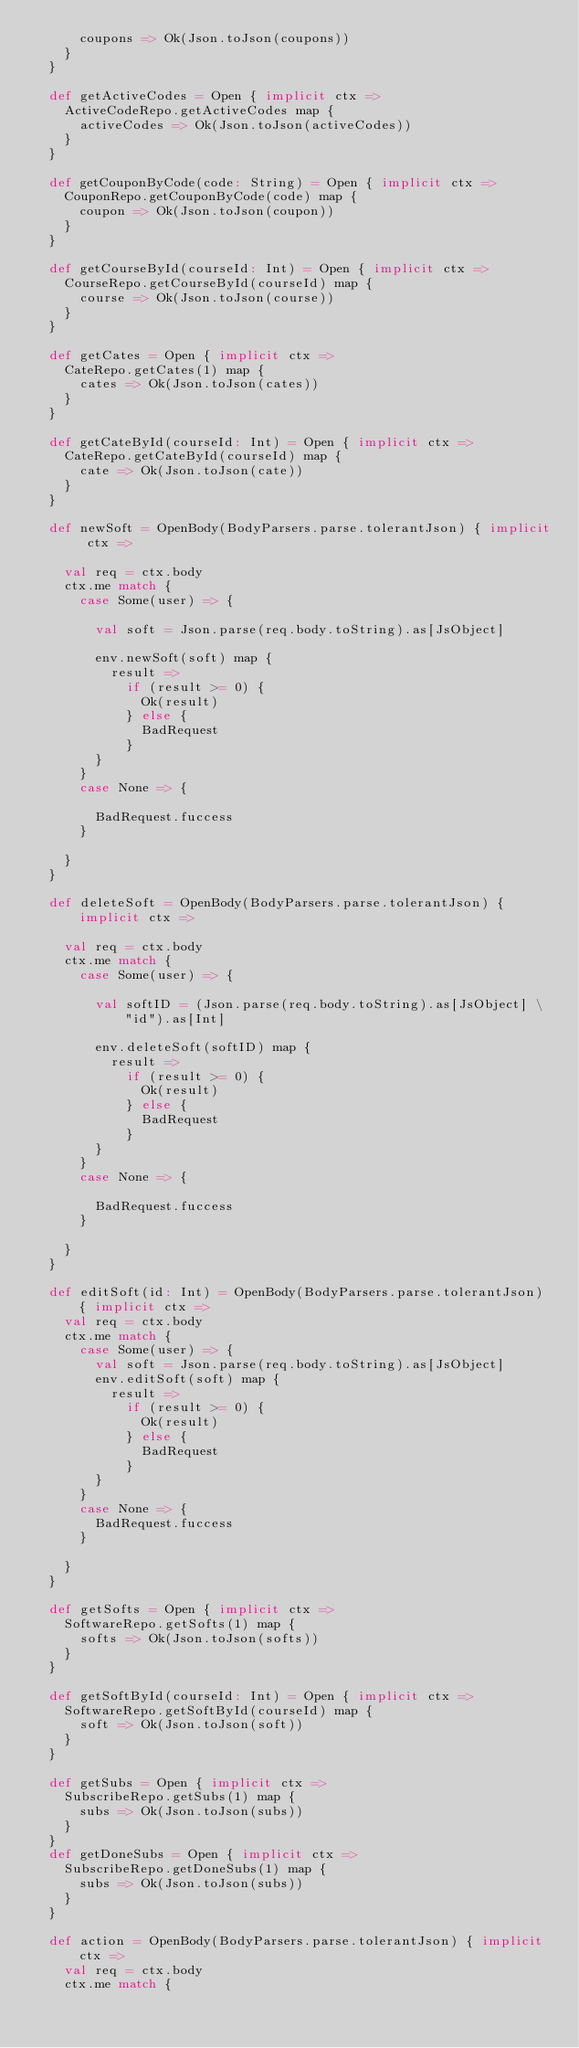<code> <loc_0><loc_0><loc_500><loc_500><_Scala_>      coupons => Ok(Json.toJson(coupons))
    }
  }

  def getActiveCodes = Open { implicit ctx =>
    ActiveCodeRepo.getActiveCodes map {
      activeCodes => Ok(Json.toJson(activeCodes))
    }
  }

  def getCouponByCode(code: String) = Open { implicit ctx =>
    CouponRepo.getCouponByCode(code) map {
      coupon => Ok(Json.toJson(coupon))
    }
  }

  def getCourseById(courseId: Int) = Open { implicit ctx =>
    CourseRepo.getCourseById(courseId) map {
      course => Ok(Json.toJson(course))
    }
  }

  def getCates = Open { implicit ctx =>
    CateRepo.getCates(1) map {
      cates => Ok(Json.toJson(cates))
    }
  }

  def getCateById(courseId: Int) = Open { implicit ctx =>
    CateRepo.getCateById(courseId) map {
      cate => Ok(Json.toJson(cate))
    }
  }

  def newSoft = OpenBody(BodyParsers.parse.tolerantJson) { implicit ctx =>

    val req = ctx.body
    ctx.me match {
      case Some(user) => {

        val soft = Json.parse(req.body.toString).as[JsObject]

        env.newSoft(soft) map {
          result =>
            if (result >= 0) {
              Ok(result)
            } else {
              BadRequest
            }
        }
      }
      case None => {

        BadRequest.fuccess
      }

    }
  }

  def deleteSoft = OpenBody(BodyParsers.parse.tolerantJson) { implicit ctx =>

    val req = ctx.body
    ctx.me match {
      case Some(user) => {

        val softID = (Json.parse(req.body.toString).as[JsObject] \ "id").as[Int]

        env.deleteSoft(softID) map {
          result =>
            if (result >= 0) {
              Ok(result)
            } else {
              BadRequest
            }
        }
      }
      case None => {

        BadRequest.fuccess
      }

    }
  }

  def editSoft(id: Int) = OpenBody(BodyParsers.parse.tolerantJson) { implicit ctx =>
    val req = ctx.body
    ctx.me match {
      case Some(user) => {
        val soft = Json.parse(req.body.toString).as[JsObject]
        env.editSoft(soft) map {
          result =>
            if (result >= 0) {
              Ok(result)
            } else {
              BadRequest
            }
        }
      }
      case None => {
        BadRequest.fuccess
      }

    }
  }

  def getSofts = Open { implicit ctx =>
    SoftwareRepo.getSofts(1) map {
      softs => Ok(Json.toJson(softs))
    }
  }

  def getSoftById(courseId: Int) = Open { implicit ctx =>
    SoftwareRepo.getSoftById(courseId) map {
      soft => Ok(Json.toJson(soft))
    }
  }

  def getSubs = Open { implicit ctx =>
    SubscribeRepo.getSubs(1) map {
      subs => Ok(Json.toJson(subs))
    }
  }
  def getDoneSubs = Open { implicit ctx =>
    SubscribeRepo.getDoneSubs(1) map {
      subs => Ok(Json.toJson(subs))
    }
  }

  def action = OpenBody(BodyParsers.parse.tolerantJson) { implicit ctx =>
    val req = ctx.body
    ctx.me match {</code> 